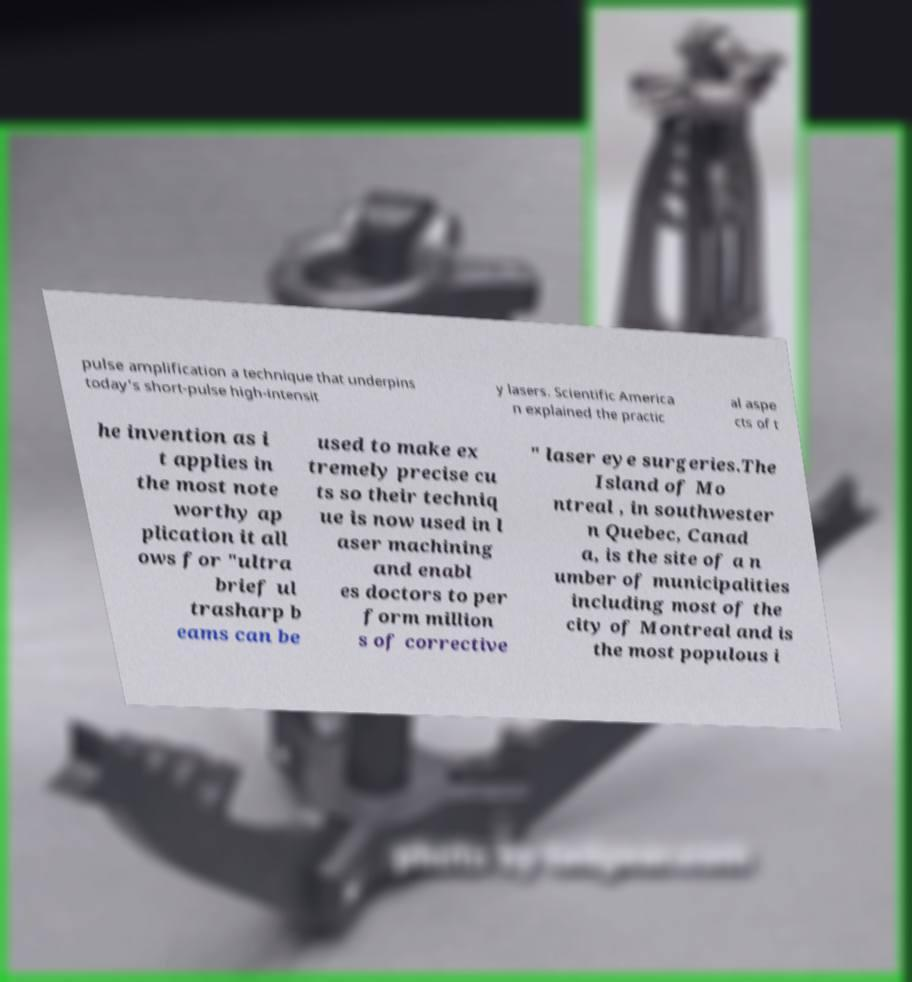I need the written content from this picture converted into text. Can you do that? pulse amplification a technique that underpins today's short-pulse high-intensit y lasers. Scientific America n explained the practic al aspe cts of t he invention as i t applies in the most note worthy ap plication it all ows for "ultra brief ul trasharp b eams can be used to make ex tremely precise cu ts so their techniq ue is now used in l aser machining and enabl es doctors to per form million s of corrective " laser eye surgeries.The Island of Mo ntreal , in southwester n Quebec, Canad a, is the site of a n umber of municipalities including most of the city of Montreal and is the most populous i 